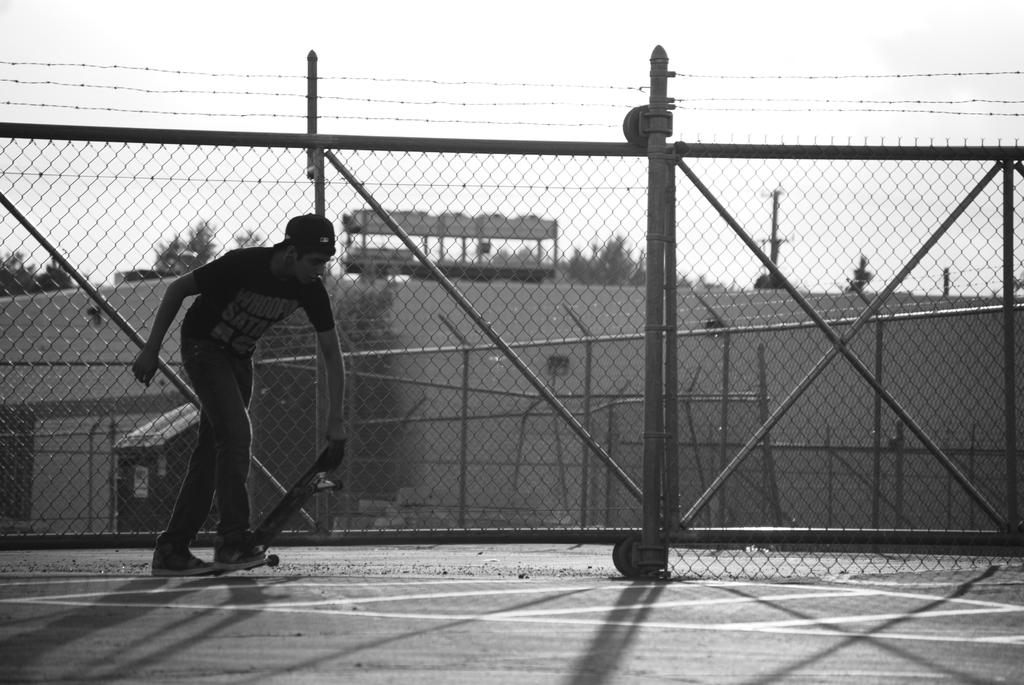What is the main subject of the image? There is a person in the image. What is the person doing in the image? The person is standing on the ground. What object does the person have with them? The person has a skateboard. What can be seen in the background of the image? There is fencing, trees, a building, and the sky visible in the background of the image. Where is the faucet located in the image? There is no faucet present in the image. What kind of trouble is the person experiencing in the image? There is no indication of trouble in the image; the person is simply standing on the ground with a skateboard. 